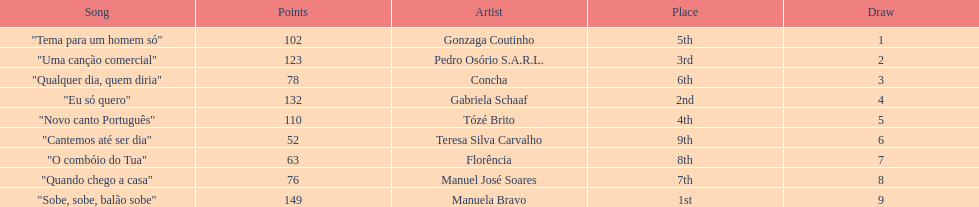Which artist came in last place? Teresa Silva Carvalho. 